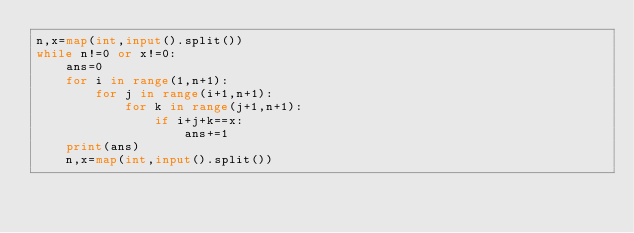Convert code to text. <code><loc_0><loc_0><loc_500><loc_500><_Python_>n,x=map(int,input().split())
while n!=0 or x!=0:
    ans=0
    for i in range(1,n+1):
        for j in range(i+1,n+1):
            for k in range(j+1,n+1):
                if i+j+k==x:
                    ans+=1
    print(ans)
    n,x=map(int,input().split())

</code> 